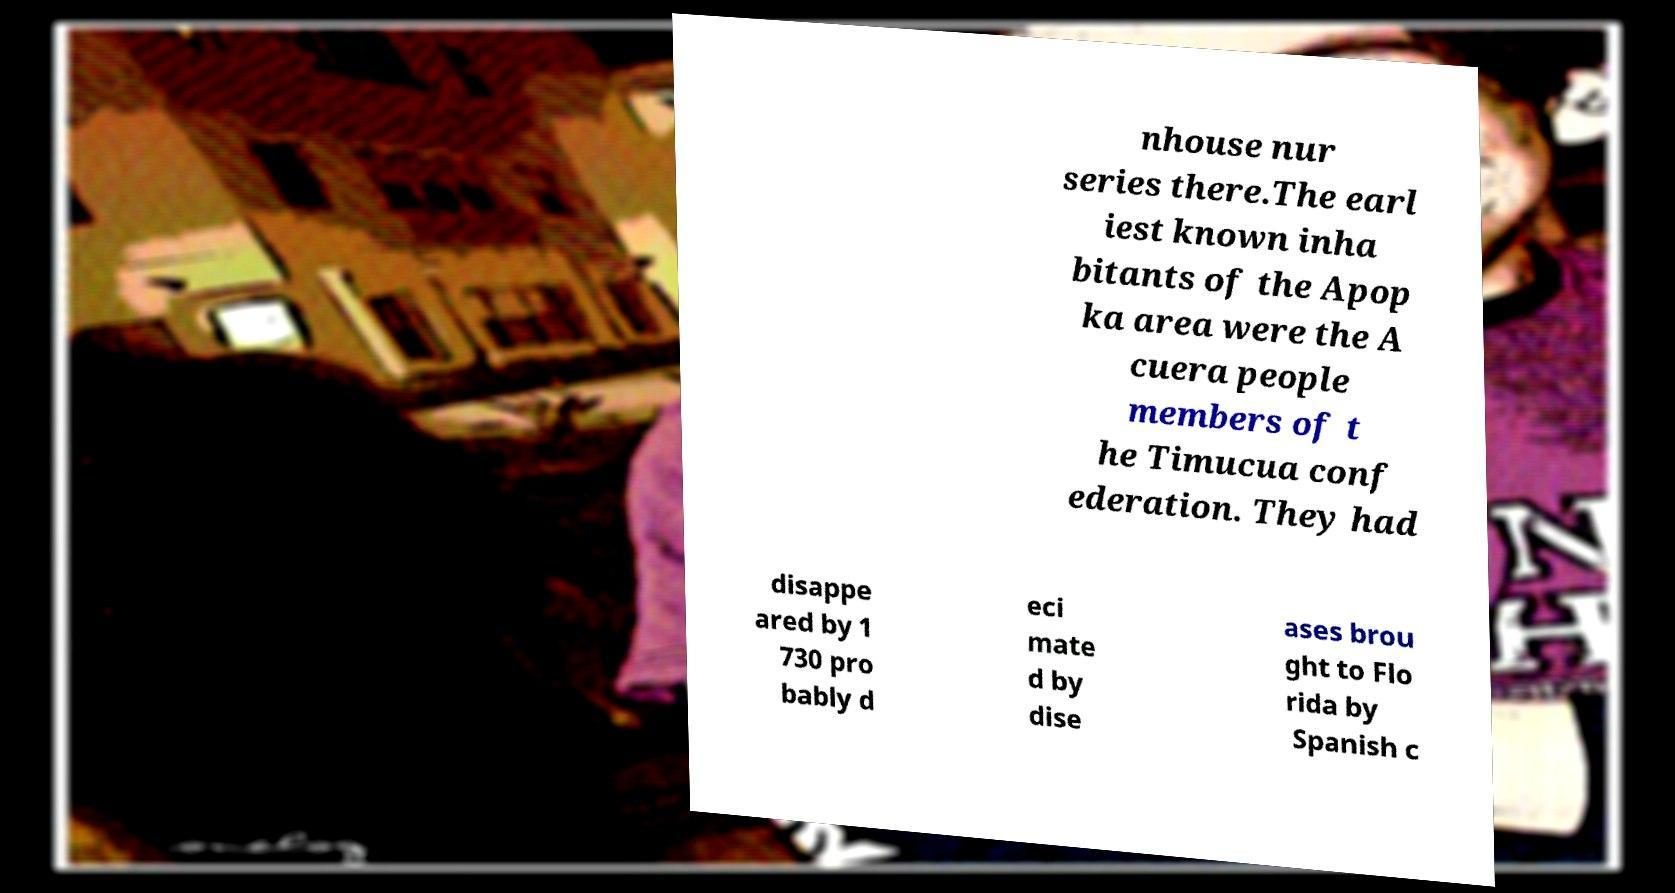Can you accurately transcribe the text from the provided image for me? nhouse nur series there.The earl iest known inha bitants of the Apop ka area were the A cuera people members of t he Timucua conf ederation. They had disappe ared by 1 730 pro bably d eci mate d by dise ases brou ght to Flo rida by Spanish c 